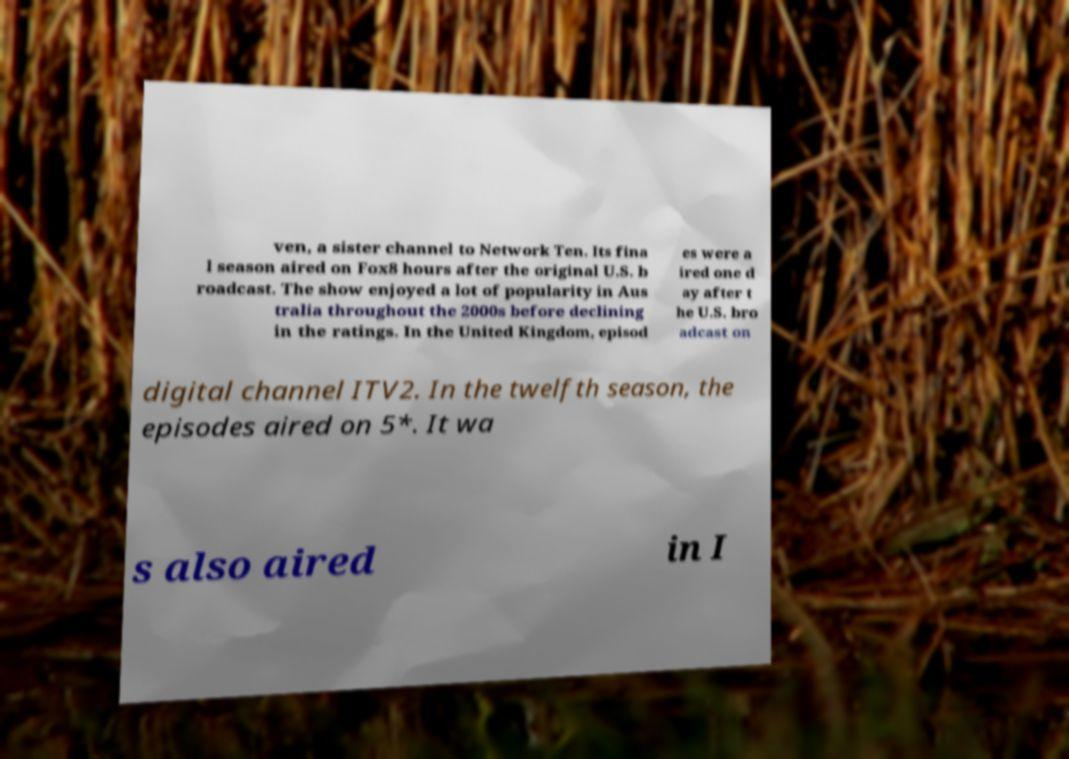Can you accurately transcribe the text from the provided image for me? ven, a sister channel to Network Ten. Its fina l season aired on Fox8 hours after the original U.S. b roadcast. The show enjoyed a lot of popularity in Aus tralia throughout the 2000s before declining in the ratings. In the United Kingdom, episod es were a ired one d ay after t he U.S. bro adcast on digital channel ITV2. In the twelfth season, the episodes aired on 5*. It wa s also aired in I 